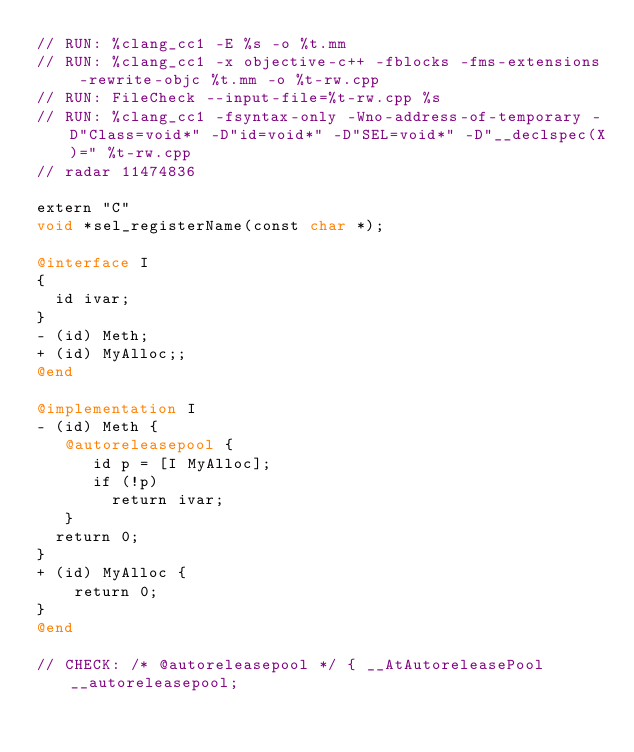Convert code to text. <code><loc_0><loc_0><loc_500><loc_500><_ObjectiveC_>// RUN: %clang_cc1 -E %s -o %t.mm
// RUN: %clang_cc1 -x objective-c++ -fblocks -fms-extensions -rewrite-objc %t.mm -o %t-rw.cpp
// RUN: FileCheck --input-file=%t-rw.cpp %s
// RUN: %clang_cc1 -fsyntax-only -Wno-address-of-temporary -D"Class=void*" -D"id=void*" -D"SEL=void*" -D"__declspec(X)=" %t-rw.cpp
// radar 11474836

extern "C"
void *sel_registerName(const char *);

@interface I
{
  id ivar;
}
- (id) Meth;
+ (id) MyAlloc;;
@end

@implementation I
- (id) Meth {
   @autoreleasepool {
      id p = [I MyAlloc];
      if (!p)
        return ivar;
   }
  return 0;
}
+ (id) MyAlloc {
    return 0;
}
@end

// CHECK: /* @autoreleasepool */ { __AtAutoreleasePool __autoreleasepool;
</code> 